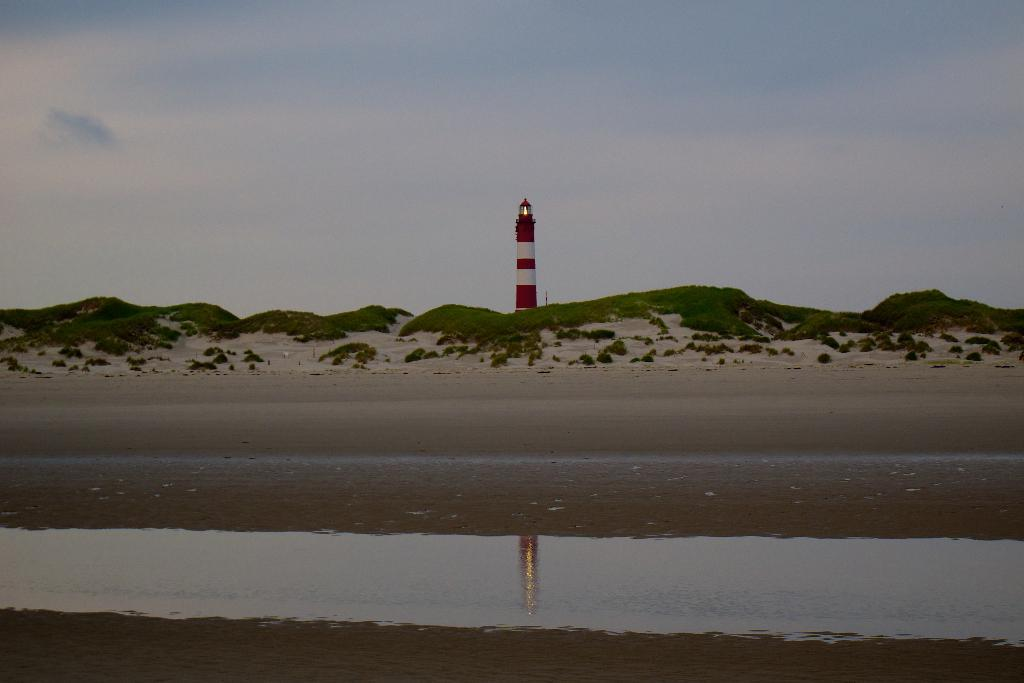What structure is the main subject of the image? There is a lighthouse in the image. What type of terrain surrounds the lighthouse? There is grass on the ground in the image. What natural feature is visible in the image? There is water visible in the image. What is the condition of the sky in the image? The sky is cloudy in the image. What type of fuel is being used by the tramp in the image? There is no tramp present in the image, and therefore no fuel can be associated with it. 